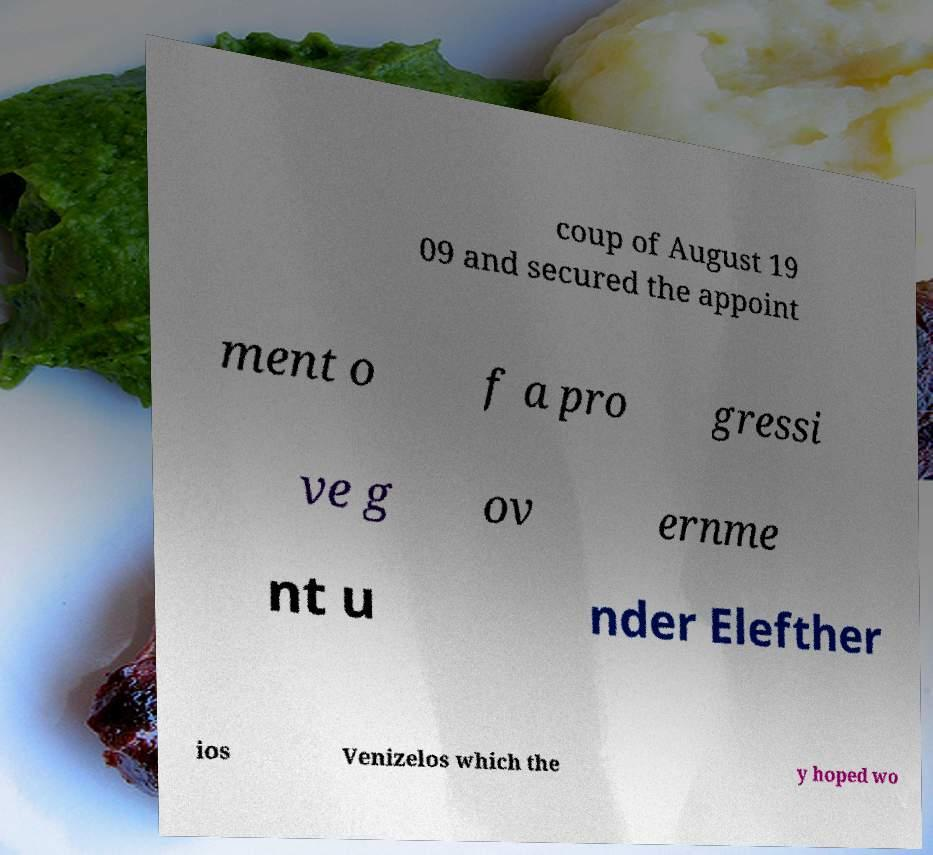For documentation purposes, I need the text within this image transcribed. Could you provide that? coup of August 19 09 and secured the appoint ment o f a pro gressi ve g ov ernme nt u nder Elefther ios Venizelos which the y hoped wo 